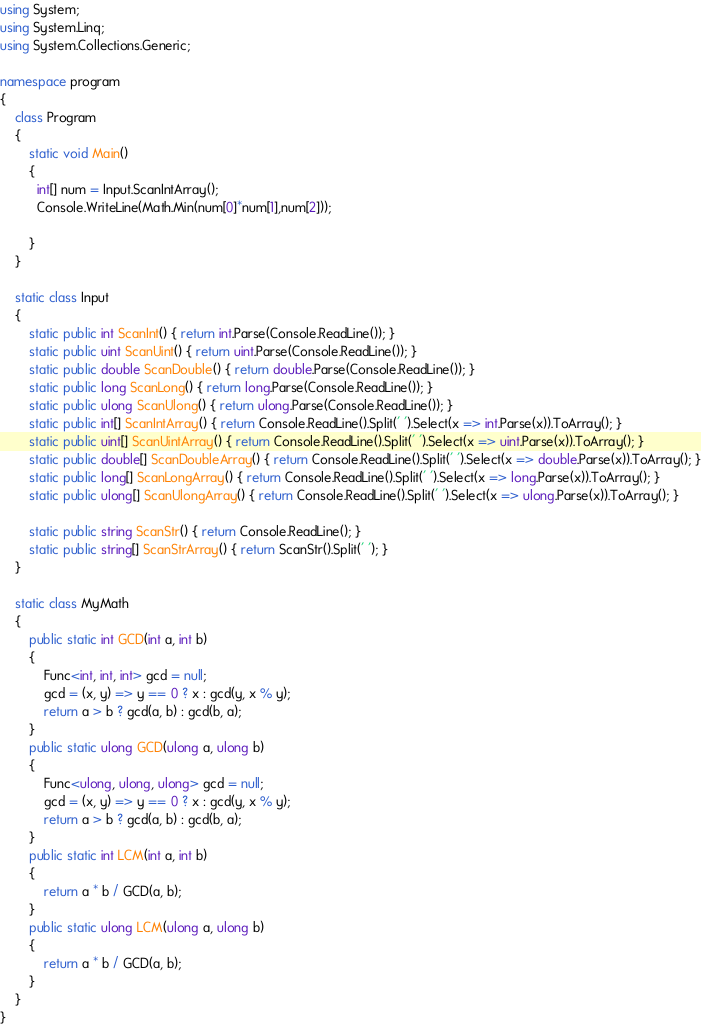<code> <loc_0><loc_0><loc_500><loc_500><_C#_>using System;
using System.Linq;
using System.Collections.Generic;

namespace program
{
    class Program
    {
        static void Main()
        {
          int[] num = Input.ScanIntArray();
          Console.WriteLine(Math.Min(num[0]*num[1],num[2]));
            
        }
    }

    static class Input
    {
        static public int ScanInt() { return int.Parse(Console.ReadLine()); }
        static public uint ScanUint() { return uint.Parse(Console.ReadLine()); }
        static public double ScanDouble() { return double.Parse(Console.ReadLine()); }
        static public long ScanLong() { return long.Parse(Console.ReadLine()); }
        static public ulong ScanUlong() { return ulong.Parse(Console.ReadLine()); }
        static public int[] ScanIntArray() { return Console.ReadLine().Split(' ').Select(x => int.Parse(x)).ToArray(); }
        static public uint[] ScanUintArray() { return Console.ReadLine().Split(' ').Select(x => uint.Parse(x)).ToArray(); }
        static public double[] ScanDoubleArray() { return Console.ReadLine().Split(' ').Select(x => double.Parse(x)).ToArray(); }
        static public long[] ScanLongArray() { return Console.ReadLine().Split(' ').Select(x => long.Parse(x)).ToArray(); }
        static public ulong[] ScanUlongArray() { return Console.ReadLine().Split(' ').Select(x => ulong.Parse(x)).ToArray(); }

        static public string ScanStr() { return Console.ReadLine(); }
        static public string[] ScanStrArray() { return ScanStr().Split(' '); }
    }

    static class MyMath
    {
        public static int GCD(int a, int b)
        {
            Func<int, int, int> gcd = null;
            gcd = (x, y) => y == 0 ? x : gcd(y, x % y);
            return a > b ? gcd(a, b) : gcd(b, a);
        }
        public static ulong GCD(ulong a, ulong b)
        {
            Func<ulong, ulong, ulong> gcd = null;
            gcd = (x, y) => y == 0 ? x : gcd(y, x % y);
            return a > b ? gcd(a, b) : gcd(b, a);
        }
        public static int LCM(int a, int b)
        {
            return a * b / GCD(a, b);
        }
        public static ulong LCM(ulong a, ulong b)
        {
            return a * b / GCD(a, b);
        }
    }
}
</code> 